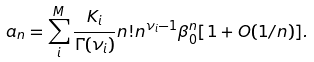Convert formula to latex. <formula><loc_0><loc_0><loc_500><loc_500>a _ { n } = \sum _ { i } ^ { M } \frac { K _ { i } } { \Gamma ( \nu _ { i } ) } n ! n ^ { \nu _ { i } - 1 } \beta _ { 0 } ^ { n } [ 1 + O ( 1 / n ) ] .</formula> 